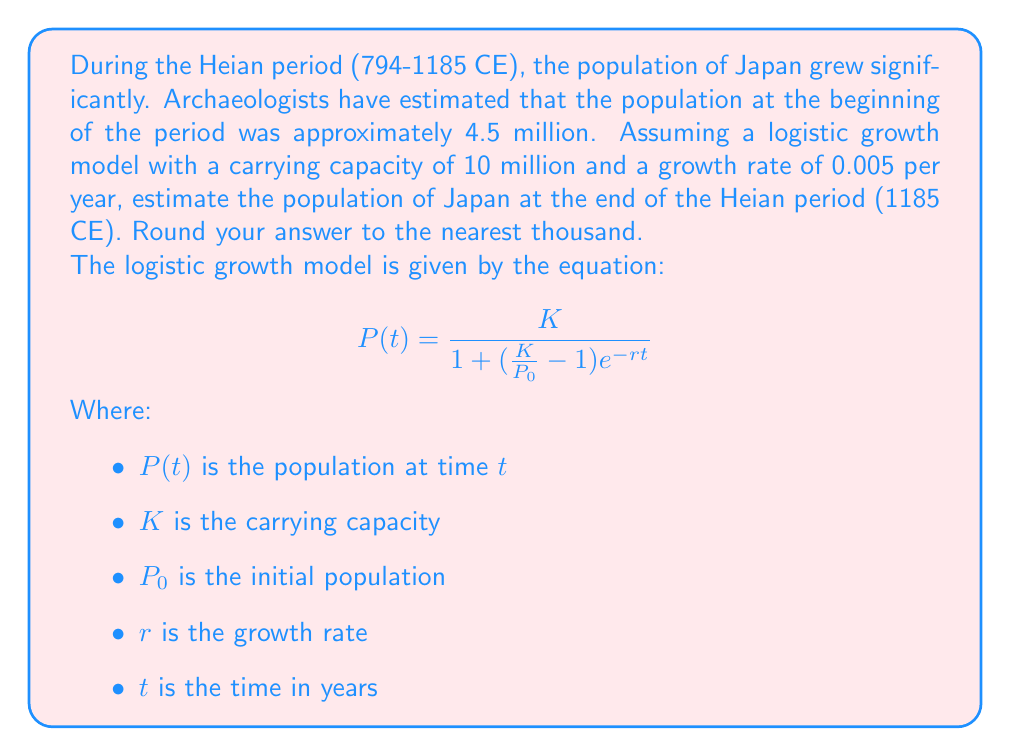Help me with this question. To solve this problem, we need to use the logistic growth model equation and plug in the given values:

$K = 10,000,000$ (carrying capacity)
$P_0 = 4,500,000$ (initial population)
$r = 0.005$ (growth rate per year)
$t = 1185 - 794 = 391$ years (duration of the Heian period)

Let's substitute these values into the equation:

$$P(391) = \frac{10,000,000}{1 + (\frac{10,000,000}{4,500,000} - 1)e^{-0.005 \times 391}}$$

Now, let's solve this step-by-step:

1. Calculate $\frac{K}{P_0} - 1$:
   $\frac{10,000,000}{4,500,000} - 1 = 2.22222... - 1 = 1.22222...$

2. Calculate $e^{-rt}$:
   $e^{-0.005 \times 391} = e^{-1.955} \approx 0.14169$

3. Multiply the results from steps 1 and 2:
   $1.22222... \times 0.14169 \approx 0.17318$

4. Add 1 to the result from step 3:
   $1 + 0.17318 = 1.17318$

5. Divide $K$ by the result from step 4:
   $\frac{10,000,000}{1.17318} \approx 8,524,115$

6. Round to the nearest thousand:
   $8,524,115 \approx 8,524,000$

Therefore, the estimated population of Japan at the end of the Heian period (1185 CE) is approximately 8,524,000.
Answer: 8,524,000 